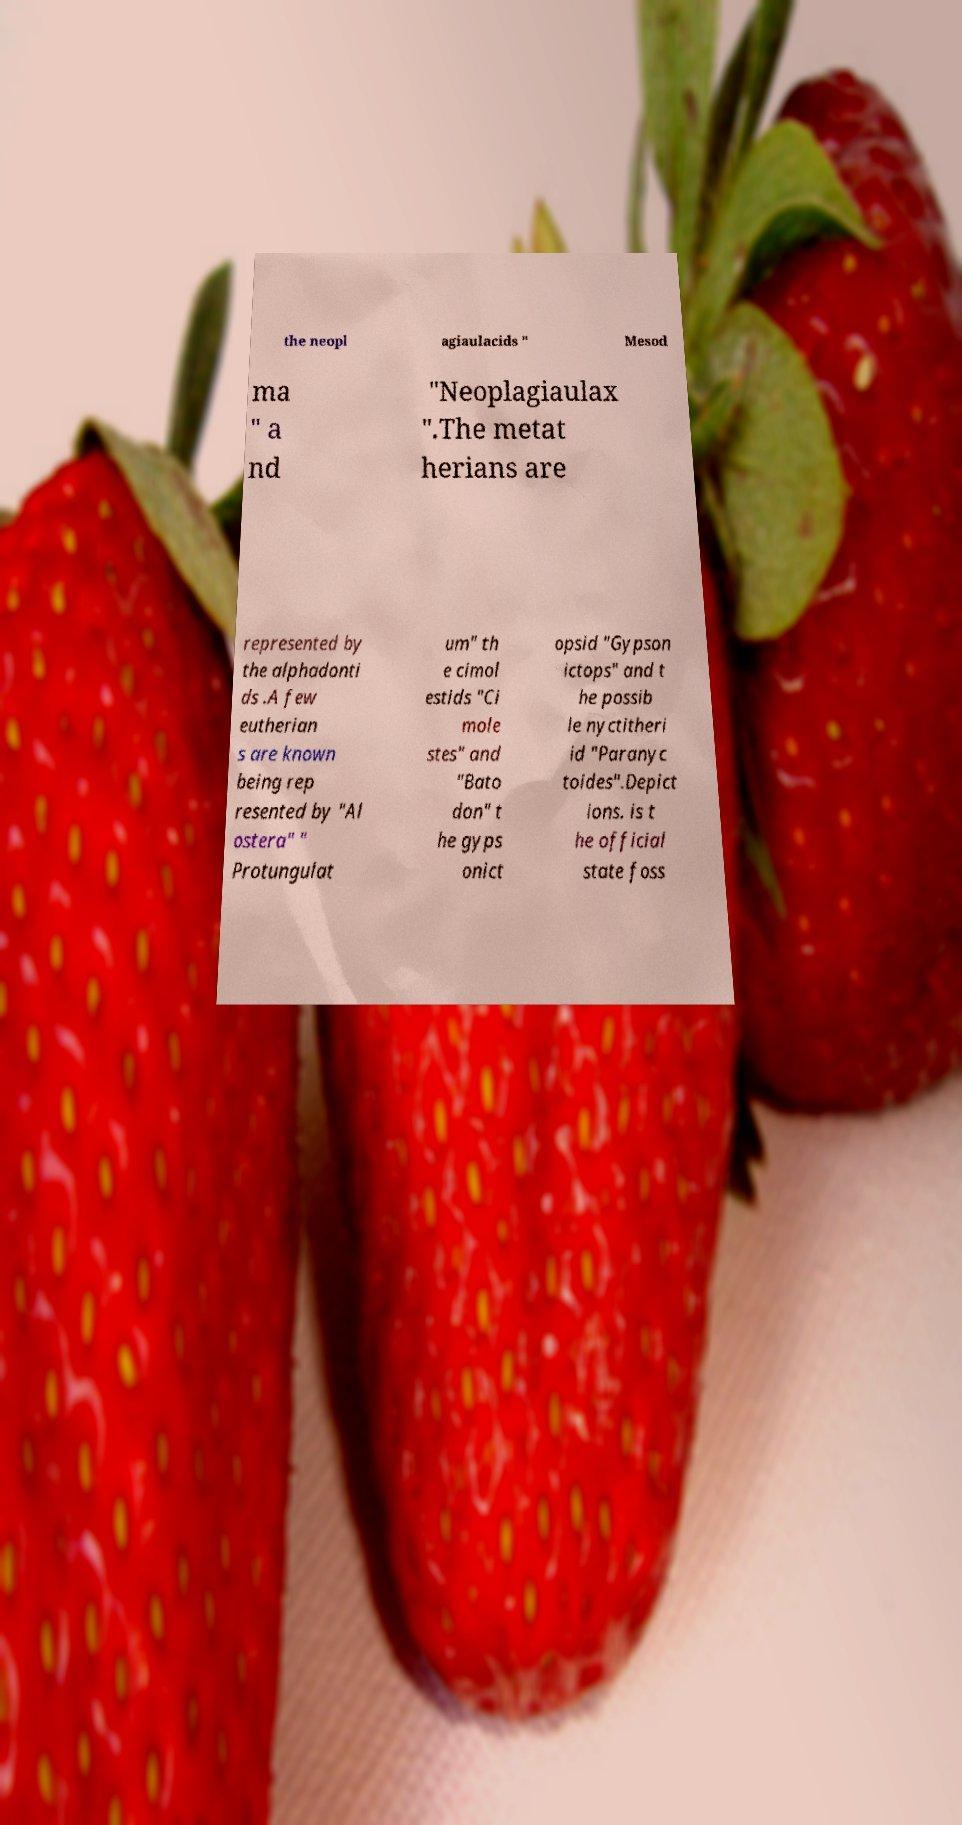I need the written content from this picture converted into text. Can you do that? the neopl agiaulacids " Mesod ma " a nd "Neoplagiaulax ".The metat herians are represented by the alphadonti ds .A few eutherian s are known being rep resented by "Al ostera" " Protungulat um" th e cimol estids "Ci mole stes" and "Bato don" t he gyps onict opsid "Gypson ictops" and t he possib le nyctitheri id "Paranyc toides".Depict ions. is t he official state foss 